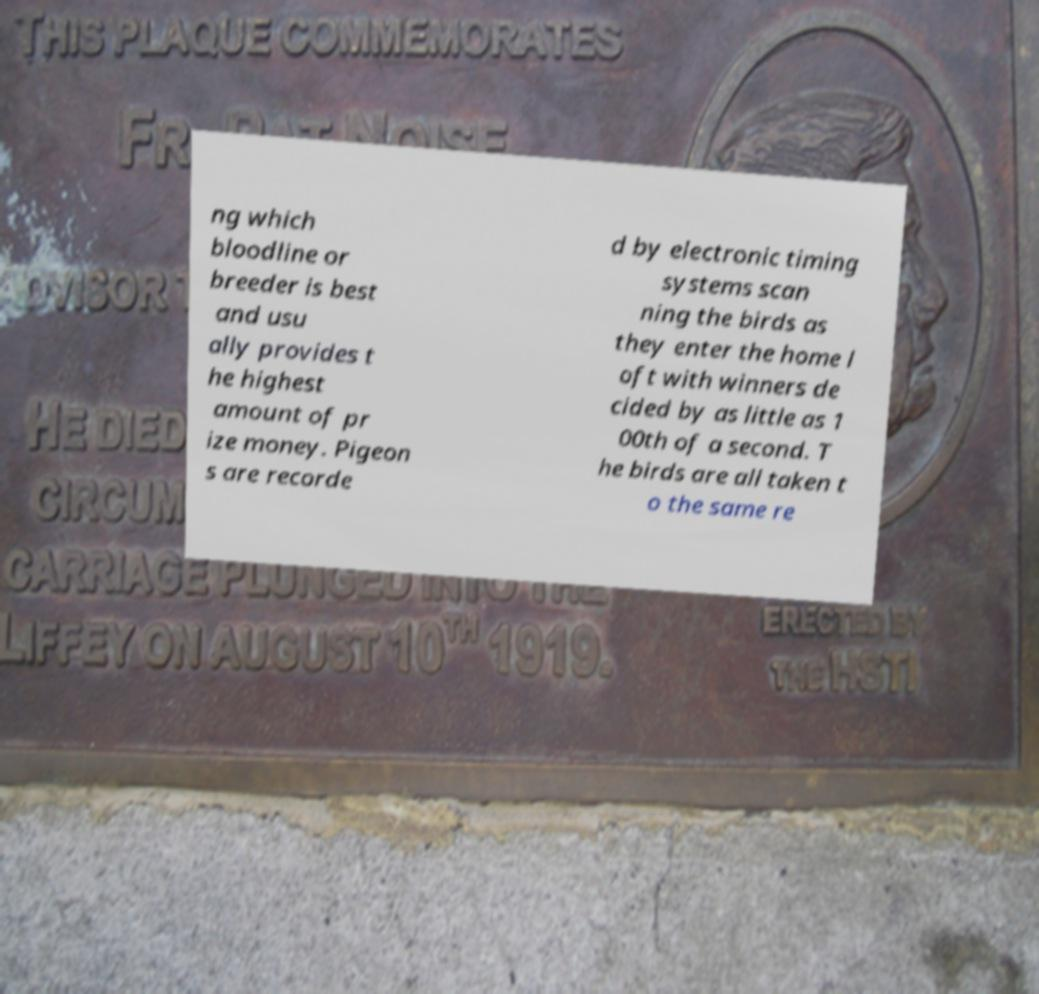Can you accurately transcribe the text from the provided image for me? ng which bloodline or breeder is best and usu ally provides t he highest amount of pr ize money. Pigeon s are recorde d by electronic timing systems scan ning the birds as they enter the home l oft with winners de cided by as little as 1 00th of a second. T he birds are all taken t o the same re 